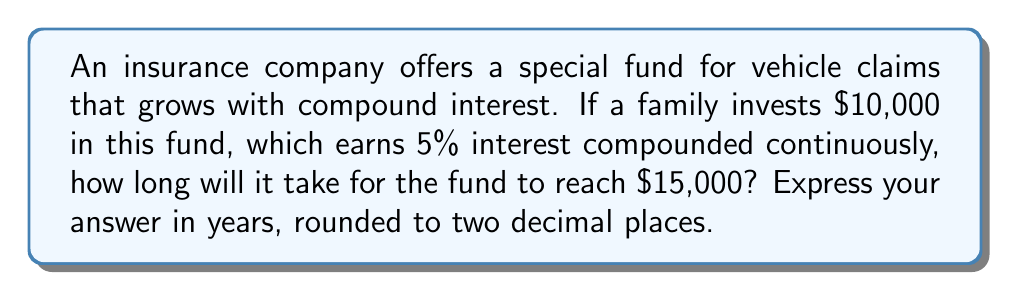What is the answer to this math problem? To solve this problem, we'll use the continuous compound interest formula and set up a first-order differential equation.

1) The formula for continuous compound interest is:

   $A = Pe^{rt}$

   Where:
   $A$ = Final amount
   $P$ = Principal (initial investment)
   $r$ = Interest rate (as a decimal)
   $t$ = Time in years
   $e$ = Euler's number (approximately 2.71828)

2) Given information:
   $P = 10000$
   $r = 0.05$ (5% expressed as a decimal)
   $A = 15000$

3) Substituting these values into the formula:

   $15000 = 10000e^{0.05t}$

4) Dividing both sides by 10000:

   $1.5 = e^{0.05t}$

5) Taking the natural logarithm of both sides:

   $\ln(1.5) = \ln(e^{0.05t})$

6) Simplify the right side using the properties of logarithms:

   $\ln(1.5) = 0.05t$

7) Solve for $t$ by dividing both sides by 0.05:

   $t = \frac{\ln(1.5)}{0.05}$

8) Calculate the result:

   $t \approx 8.0472$ years

9) Rounding to two decimal places:

   $t \approx 8.05$ years
Answer: 8.05 years 